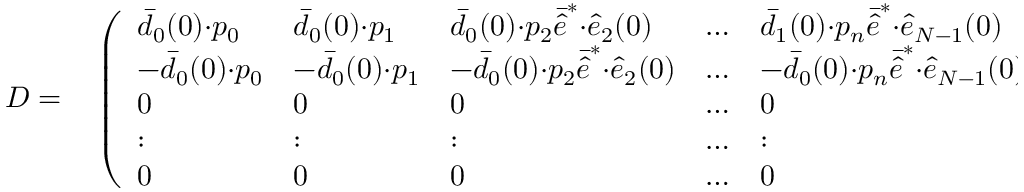Convert formula to latex. <formula><loc_0><loc_0><loc_500><loc_500>\begin{array} { r l } { D = } & \left ( \begin{array} { l l l l l } { \bar { d } _ { 0 } ( 0 ) { \cdot } p _ { 0 } } & { \bar { d } _ { 0 } ( 0 ) { \cdot } p _ { 1 } } & { \bar { d } _ { 0 } ( 0 ) { \cdot } p _ { 2 } \bar { \hat { e } } ^ { * } { \cdot } \hat { e } _ { 2 } ( 0 ) } & { \dots } & { \bar { d } _ { 1 } ( 0 ) { \cdot } p _ { n } \bar { \hat { e } } ^ { * } { \cdot } \hat { e } _ { N - 1 } ( 0 ) } \\ { - \bar { d } _ { 0 } ( 0 ) { \cdot } p _ { 0 } } & { - \bar { d } _ { 0 } ( 0 ) { \cdot } p _ { 1 } } & { - \bar { d } _ { 0 } ( 0 ) { \cdot } p _ { 2 } \bar { \hat { e } } ^ { * } { \cdot } \hat { e } _ { 2 } ( 0 ) } & { \dots } & { - \bar { d } _ { 0 } ( 0 ) { \cdot } p _ { n } \bar { \hat { e } } ^ { * } { \cdot } \hat { e } _ { N - 1 } ( 0 ) } \\ { 0 } & { 0 } & { 0 } & { \dots } & { 0 } \\ { \colon } & { \colon } & { \colon } & { \dots } & { \colon } \\ { 0 } & { 0 } & { 0 } & { \dots } & { 0 } \end{array} \right ) \, . } \end{array}</formula> 